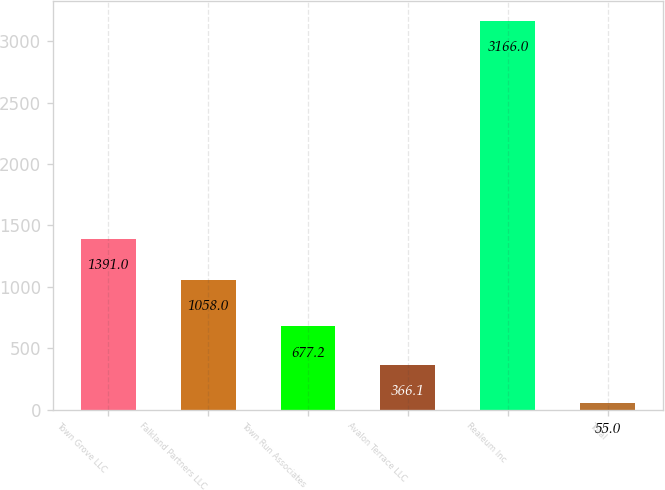<chart> <loc_0><loc_0><loc_500><loc_500><bar_chart><fcel>Town Grove LLC<fcel>Falkland Partners LLC<fcel>Town Run Associates<fcel>Avalon Terrace LLC<fcel>Realeum Inc<fcel>Total<nl><fcel>1391<fcel>1058<fcel>677.2<fcel>366.1<fcel>3166<fcel>55<nl></chart> 